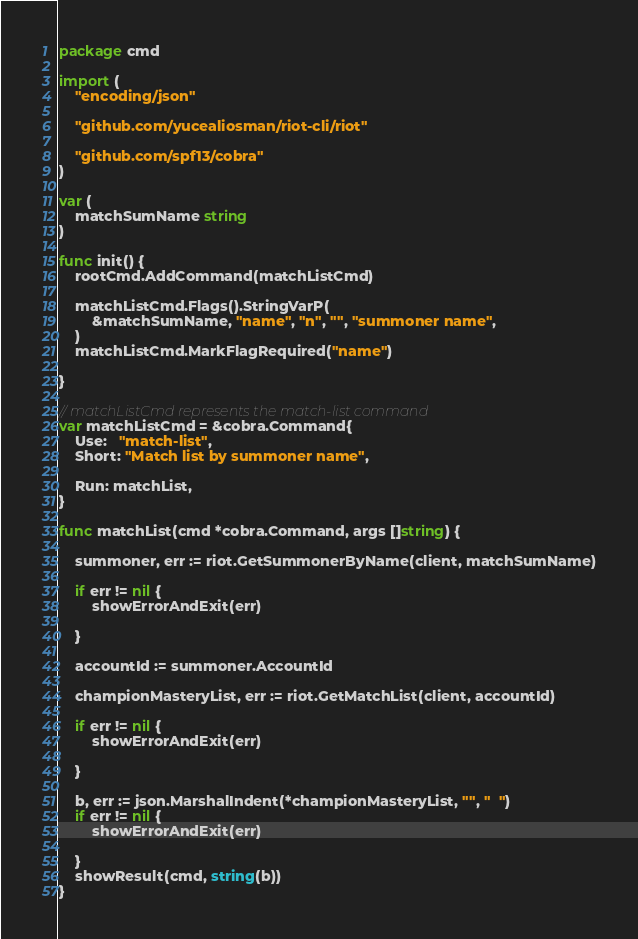Convert code to text. <code><loc_0><loc_0><loc_500><loc_500><_Go_>package cmd

import (
	"encoding/json"

	"github.com/yucealiosman/riot-cli/riot"

	"github.com/spf13/cobra"
)

var (
	matchSumName string
)

func init() {
	rootCmd.AddCommand(matchListCmd)

	matchListCmd.Flags().StringVarP(
		&matchSumName, "name", "n", "", "summoner name",
	)
	matchListCmd.MarkFlagRequired("name")

}

// matchListCmd represents the match-list command
var matchListCmd = &cobra.Command{
	Use:   "match-list",
	Short: "Match list by summoner name",

	Run: matchList,
}

func matchList(cmd *cobra.Command, args []string) {

	summoner, err := riot.GetSummonerByName(client, matchSumName)

	if err != nil {
		showErrorAndExit(err)

	}

	accountId := summoner.AccountId

	championMasteryList, err := riot.GetMatchList(client, accountId)

	if err != nil {
		showErrorAndExit(err)

	}

	b, err := json.MarshalIndent(*championMasteryList, "", "  ")
	if err != nil {
		showErrorAndExit(err)

	}
	showResult(cmd, string(b))
}
</code> 